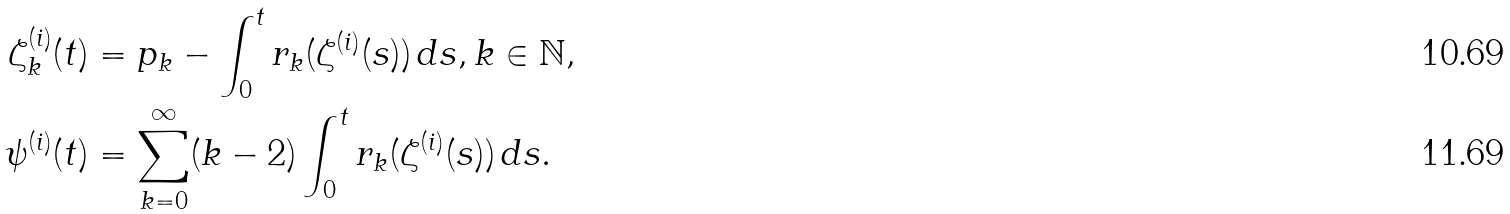<formula> <loc_0><loc_0><loc_500><loc_500>\zeta _ { k } ^ { ( i ) } ( t ) & = p _ { k } - \int _ { 0 } ^ { t } r _ { k } ( \zeta ^ { ( i ) } ( s ) ) \, d s , k \in \mathbb { N } , \\ \psi ^ { ( i ) } ( t ) & = \sum _ { k = 0 } ^ { \infty } ( k - 2 ) \int _ { 0 } ^ { t } r _ { k } ( \zeta ^ { ( i ) } ( s ) ) \, d s .</formula> 